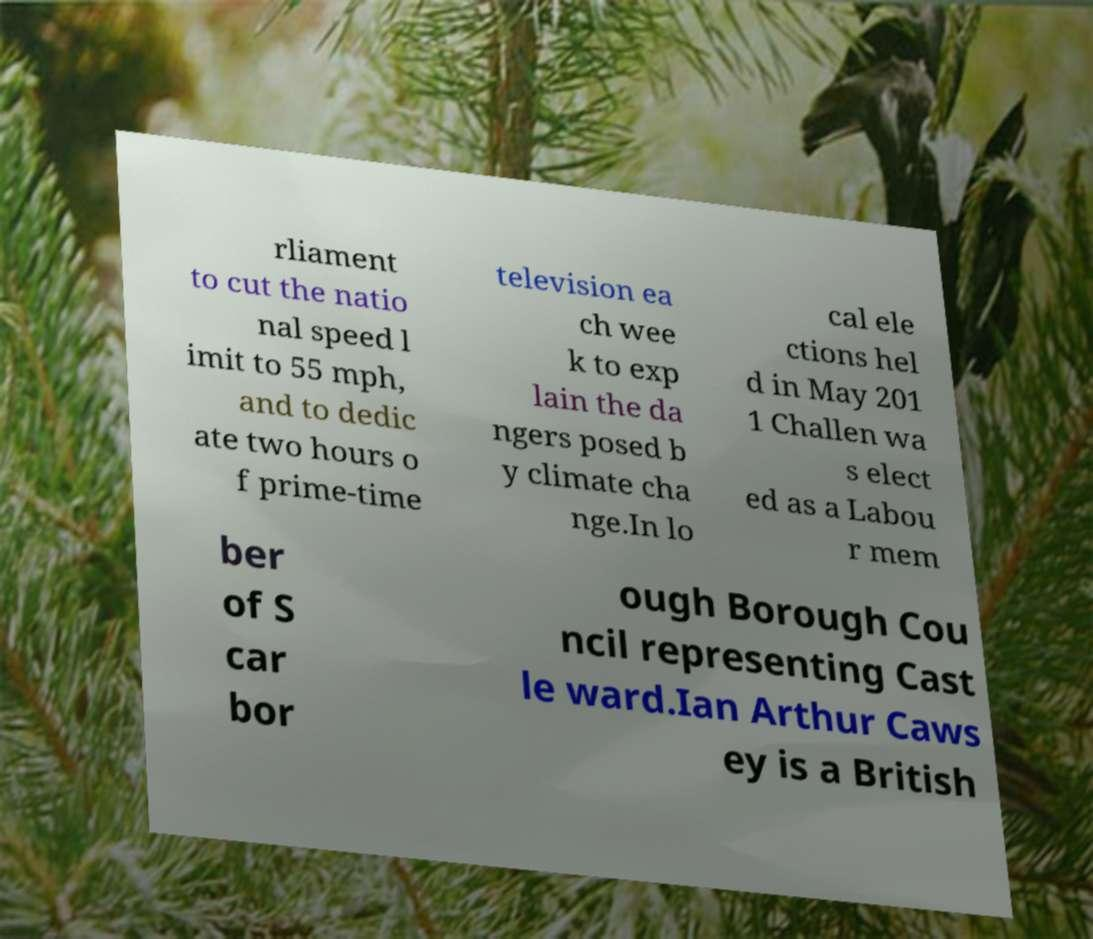There's text embedded in this image that I need extracted. Can you transcribe it verbatim? rliament to cut the natio nal speed l imit to 55 mph, and to dedic ate two hours o f prime-time television ea ch wee k to exp lain the da ngers posed b y climate cha nge.In lo cal ele ctions hel d in May 201 1 Challen wa s elect ed as a Labou r mem ber of S car bor ough Borough Cou ncil representing Cast le ward.Ian Arthur Caws ey is a British 